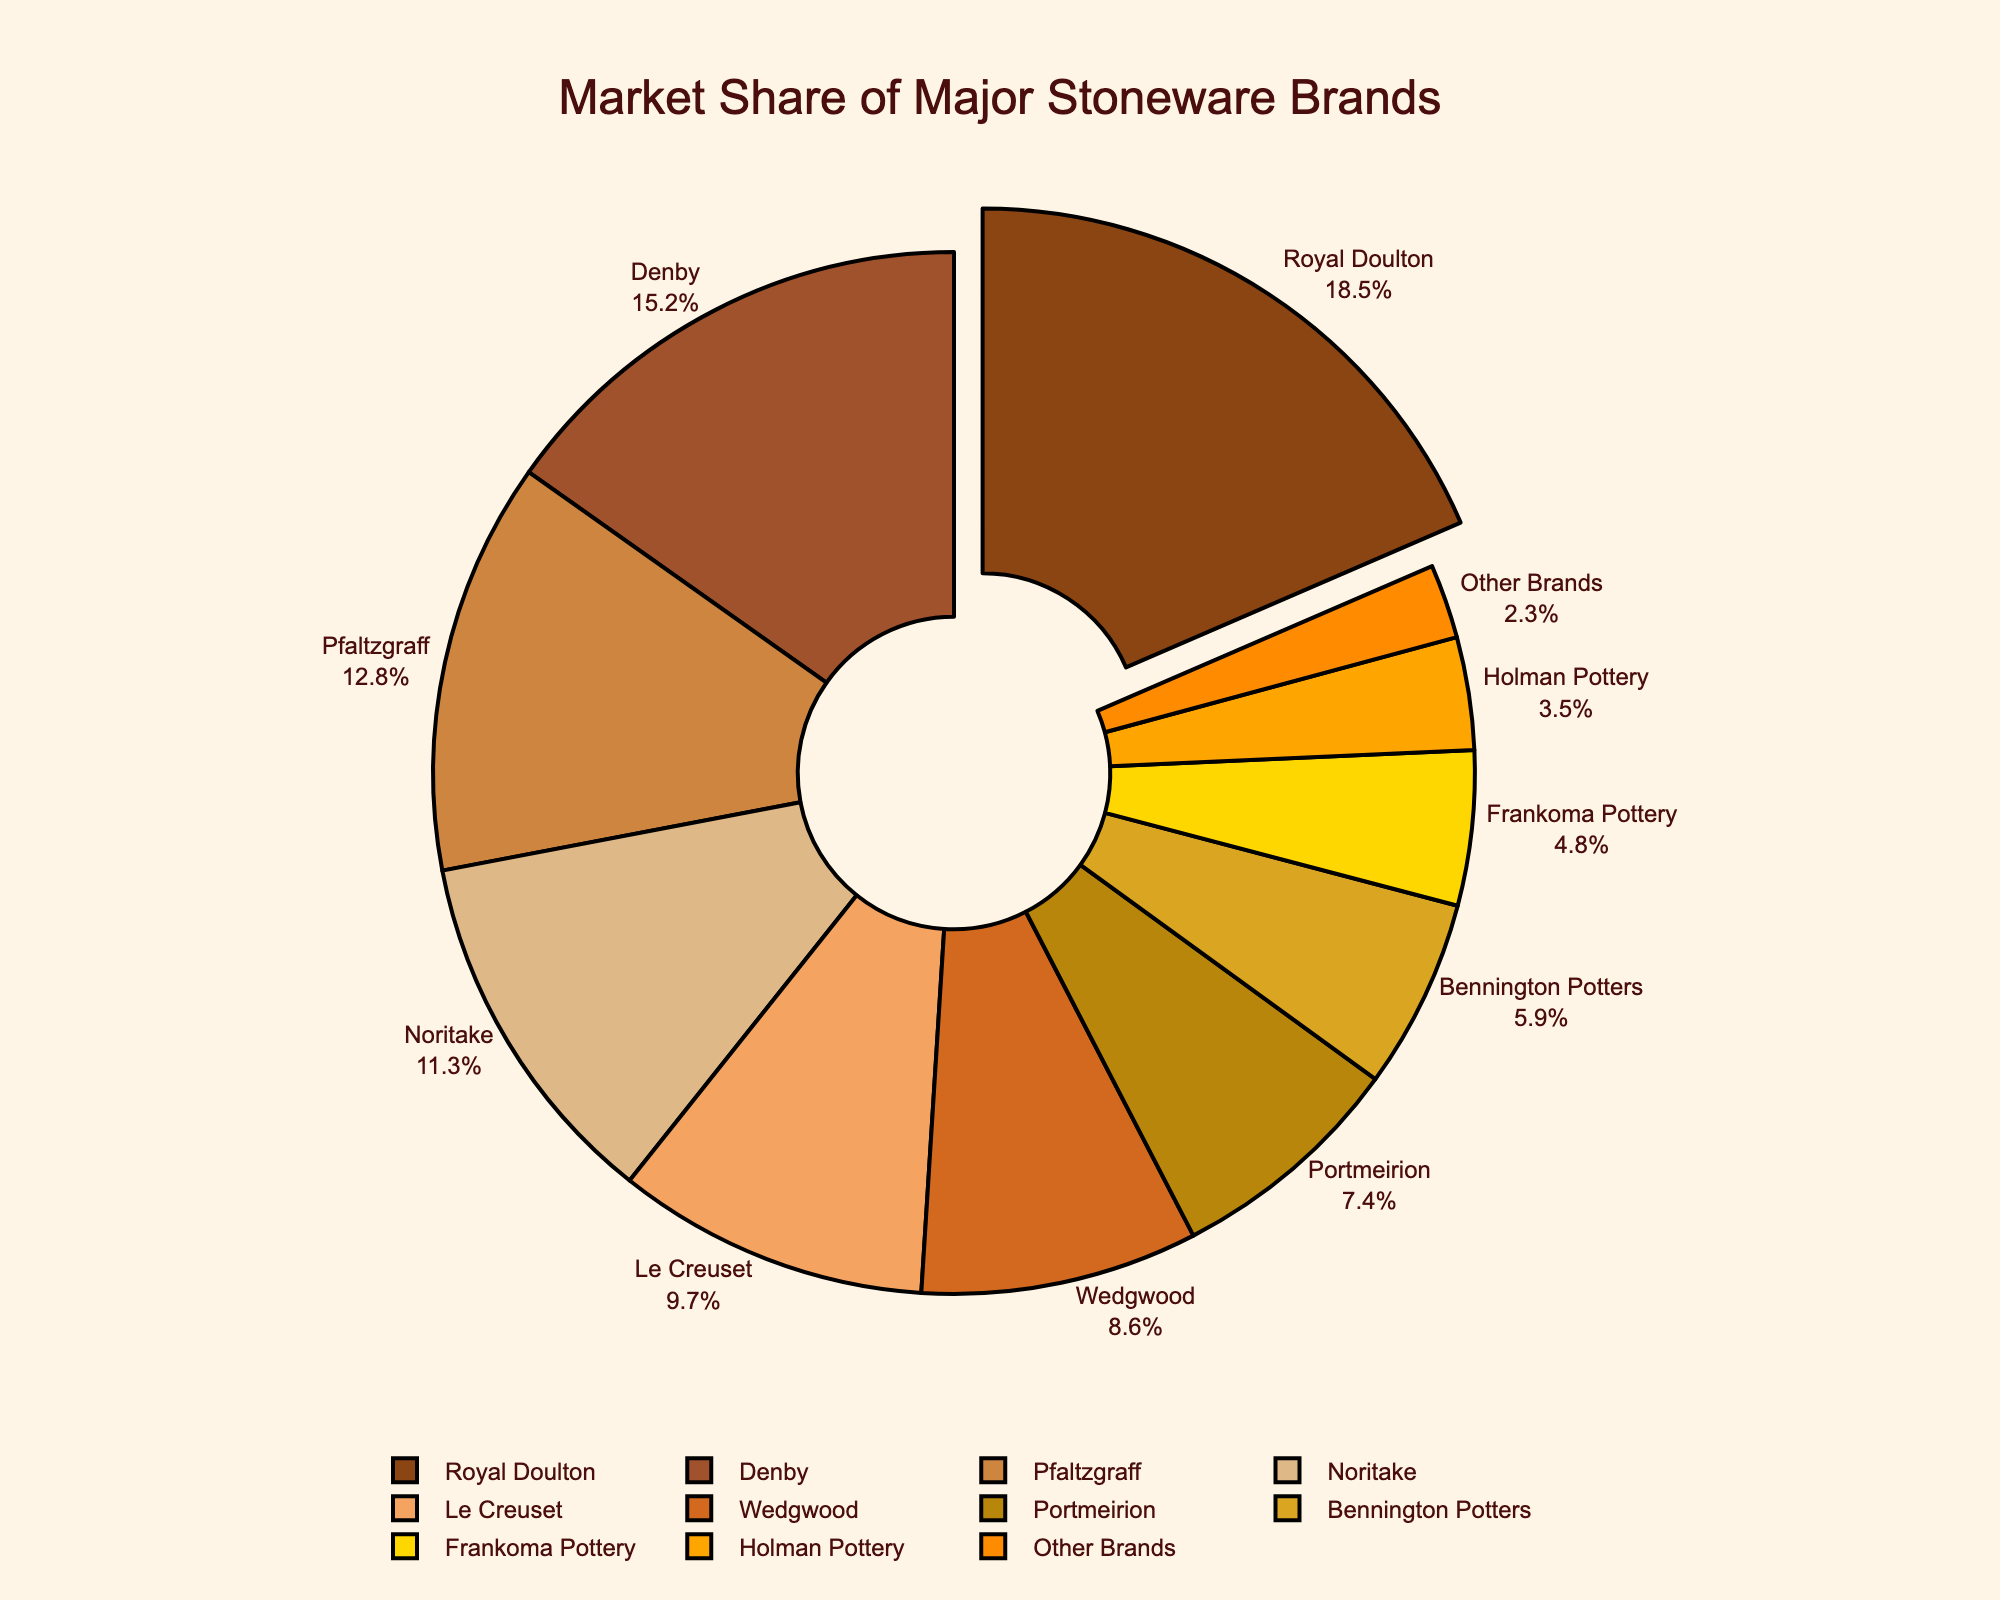What's the market share of the largest stoneware brand? The pie chart shows different brands with their respective market shares, and the segment with the highest percentage is clearly visible. The label indicates "Royal Doulton" dominates the market.
Answer: 18.5% How much more market share does Royal Doulton have compared to Wedgwood? Royal Doulton has a market share of 18.5%, and Wedgwood has a market share of 8.6%. Subtract Wedgwood's market share from Royal Doulton's: 18.5% - 8.6% = 9.9%.
Answer: 9.9% Which brands together make up more than 30% of the market? Looking at the percentages, Royal Doulton (18.5%) and Denby (15.2%) combined exceed 30%. Summing these two percentages gives 33.7%, which exceeds 30%.
Answer: Royal Doulton and Denby What is the combined market share of brands with less than 10% market share each? Adding the market shares of Noritake (11.3%), Le Creuset (9.7%), Wedgwood (8.6%), Portmeirion (7.4%), Bennington Potters (5.9%), Frankoma Pottery (4.8%), Holman Pottery (3.5%), Other Brands (2.3%): 9.7% + 8.6% + 7.4% + 5.9% + 4.8% + 3.5% + 2.3% = 32.2%.
Answer: 32.2% Which brands are represented by the smallest share of the pie chart? The segment labeled "Other Brands" represents the smallest percentage, which in this case is 2.3%.
Answer: Other Brands What is the difference in market share between the top brand and the sum of the smallest three brands? Royal Doulton has 18.5%, and the smallest three brands (Frankoma Pottery, Holman Pottery, Other Brands) have: 4.8% + 3.5% + 2.3% = 10.6%. The difference is 18.5% - 10.6% = 7.9%.
Answer: 7.9% Which two brands have the closest market share? Comparing the percentages, the closest are Noritake (11.3%) and Pfaltzgraff (12.8%), with a difference of just 1.5%.
Answer: Noritake and Pfaltzgraff Which segment is pulled out slightly from the pie chart and why? The pie chart pulls out the segment representing the largest market share to highlight the leading brand, which is Royal Doulton.
Answer: Royal Doulton What percentage of the market is held by brands other than the top three? The top three brands are Royal Doulton (18.5%), Denby (15.2%), Pfaltzgraff (12.8%). Summing them gives us 46.5%. The remaining market share is 100% - 46.5% = 53.5%.
Answer: 53.5% 